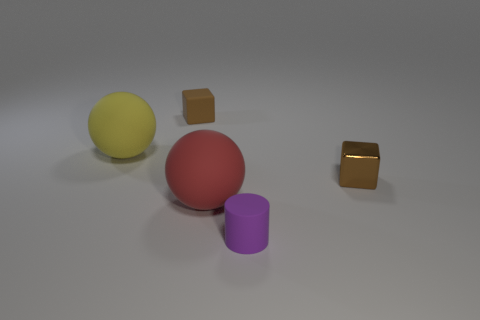Add 3 purple cubes. How many objects exist? 8 Subtract all blocks. How many objects are left? 3 Add 1 tiny green metallic balls. How many tiny green metallic balls exist? 1 Subtract 0 gray cubes. How many objects are left? 5 Subtract all purple rubber objects. Subtract all small blocks. How many objects are left? 2 Add 3 tiny purple rubber cylinders. How many tiny purple rubber cylinders are left? 4 